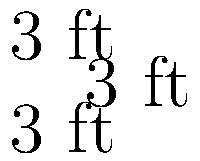A senior-friendly raised garden bed in Boston is designed as a cube with each side measuring 3 feet. If the interior and exterior surfaces need to be treated with a weatherproof sealant, what is the total surface area that needs to be covered in square feet? To solve this problem, we need to follow these steps:

1. Recognize that we need to calculate the surface area of a cube.

2. Recall the formula for the surface area of a cube:
   Surface Area = 6 * (side length)^2

3. In this case, the side length is 3 feet.

4. Plug the values into the formula:
   Surface Area = 6 * (3 ft)^2

5. Calculate:
   Surface Area = 6 * 9 ft^2 = 54 ft^2

6. Consider that both the interior and exterior surfaces need to be treated:
   Total Surface Area = 2 * 54 ft^2 = 108 ft^2

Therefore, the total surface area that needs to be covered with weatherproof sealant is 108 square feet.
Answer: 108 ft² 